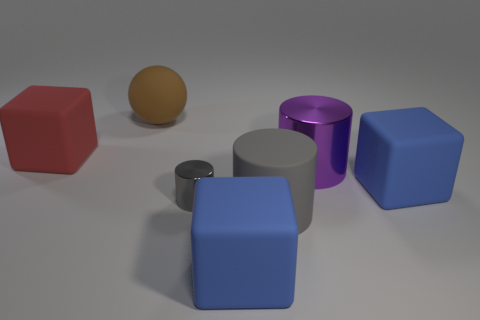How many yellow objects are large matte balls or tiny metal things?
Offer a very short reply. 0. Is the shape of the big red thing the same as the gray object that is in front of the tiny cylinder?
Offer a very short reply. No. The purple shiny object has what shape?
Your answer should be very brief. Cylinder. What material is the gray cylinder that is the same size as the red block?
Keep it short and to the point. Rubber. Is there any other thing that is the same size as the gray metallic object?
Your answer should be very brief. No. What number of objects are big purple metal balls or large objects that are behind the gray rubber object?
Provide a succinct answer. 4. What size is the gray object that is made of the same material as the purple object?
Ensure brevity in your answer.  Small. What is the shape of the blue rubber thing to the right of the big gray rubber cylinder in front of the purple metallic cylinder?
Offer a very short reply. Cube. What size is the cube that is on the left side of the matte cylinder and right of the sphere?
Offer a very short reply. Large. Are there any large purple objects of the same shape as the gray metallic object?
Make the answer very short. Yes. 